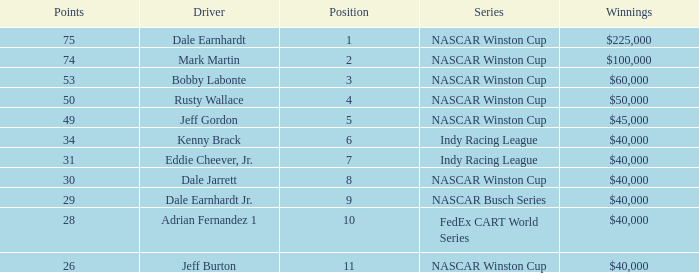In what position was the driver who won $60,000? 3.0. 